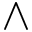<formula> <loc_0><loc_0><loc_500><loc_500>\land</formula> 